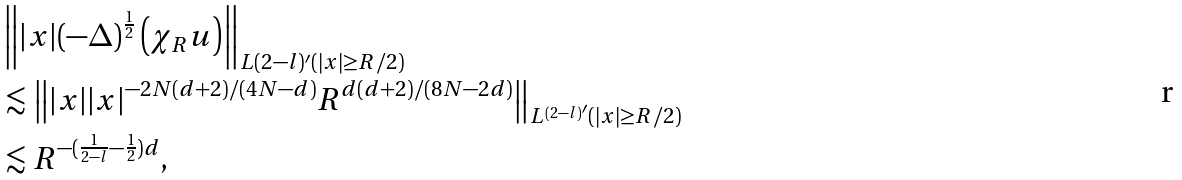<formula> <loc_0><loc_0><loc_500><loc_500>& \left \| | x | ( - \Delta ) ^ { \frac { 1 } { 2 } } \left ( \chi _ { R } u \right ) \right \| _ { L ( 2 - l ) ^ { \prime } ( | x | \geq R / 2 ) } \\ & \lesssim \left \| | x | | x | ^ { - 2 N ( d + 2 ) / ( 4 N - d ) } R ^ { d ( d + 2 ) / ( 8 N - 2 d ) } \right \| _ { L ^ { ( 2 - l ) ^ { \prime } } ( | x | \geq R / 2 ) } \\ & \lesssim R ^ { - ( \frac { 1 } { 2 - l } - \frac { 1 } { 2 } ) d } ,</formula> 